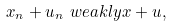Convert formula to latex. <formula><loc_0><loc_0><loc_500><loc_500>x _ { n } + u _ { n } \ w e a k l y x + u ,</formula> 